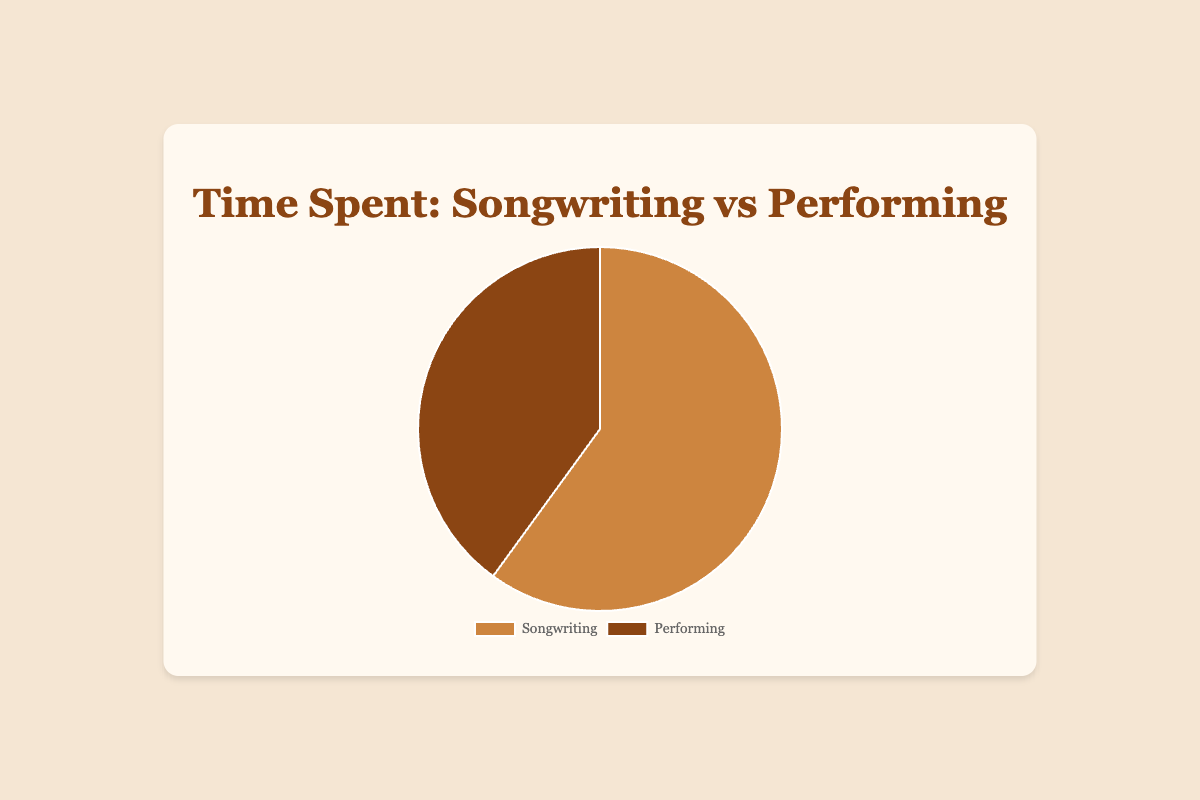Which category takes up a larger portion of the chart? By visually inspecting the chart, we can see that the sector representing "Songwriting" is larger than that for "Performing". Therefore, "Songwriting" takes up a larger portion.
Answer: Songwriting How much more time is spent on songwriting compared to performing? The difference between the percentages can be calculated by subtracting the percentage of "Performing" from that of "Songwriting" (60% - 40%). Therefore, 20% more time is spent on songwriting.
Answer: 20% What percentage of the chart does performing occupy? By examining the labels and their corresponding segments, we can see that "Performing" occupies 40% of the chart.
Answer: 40% How is the time split between songwriting and performing? Adding the percentages for both categories, we get 60% for songwriting and 40% for performing. This adds up to 100%, indicating that the time is split as 60% songwriting and 40% performing.
Answer: 60% songwriting, 40% performing Which color represents songwriting on the chart? Songwriting is represented by the larger segment, which is colored brown.
Answer: Brown What is the ratio of time spent on songwriting to performing? The time spent on songwriting (60%) divided by the time spent on performing (40%) gives a ratio. Reducing the fraction (60/40) results in a ratio of 3:2.
Answer: 3:2 If the time spent on performing would increase by 10%, what would be the new percentage for songwriting if total time is still 100%? The new percentage for performing becomes 40% + 10% = 50%. Since the total time is 100%, the new percentage for songwriting would be 100% - 50% = 50%.
Answer: 50% What fraction of the chart is performing represented by? Converting the percentage for performing (40%) into a fraction, we get 40/100, which simplifies to 2/5.
Answer: 2/5 What is the difference in size between the two segments of the chart? By subtracting the smaller segment's percentage (performing at 40%) from the larger segment's percentage (songwriting at 60%), we find the difference to be 20%.
Answer: 20% 